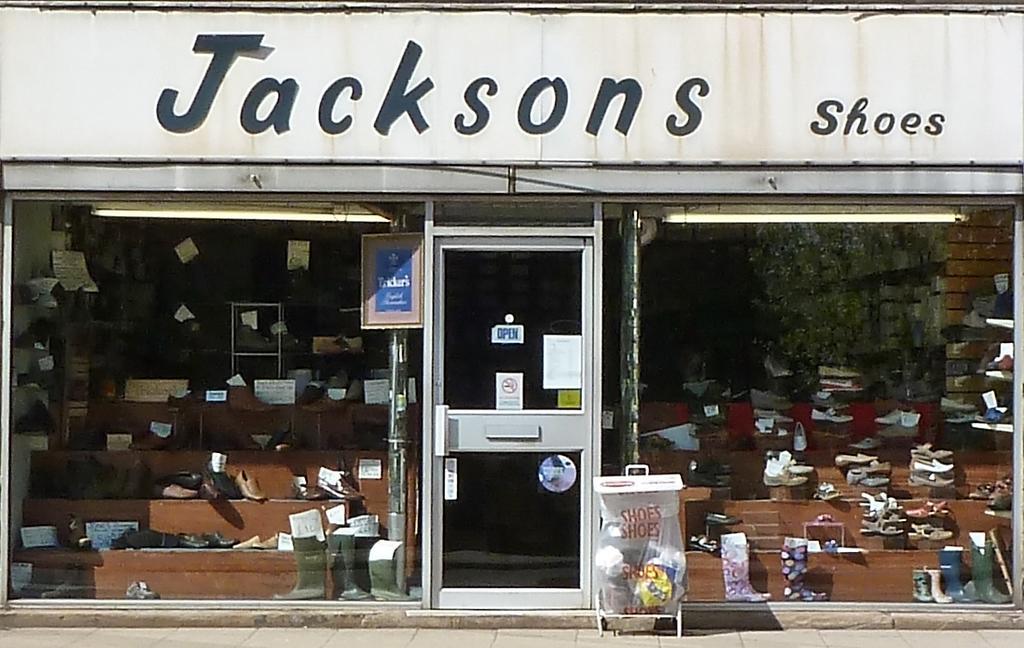In one or two sentences, can you explain what this image depicts? This image consists of a shop in which there are many shoes. In the middle, there is a door. At the bottom, there is a floor. At the top, there is a board. 